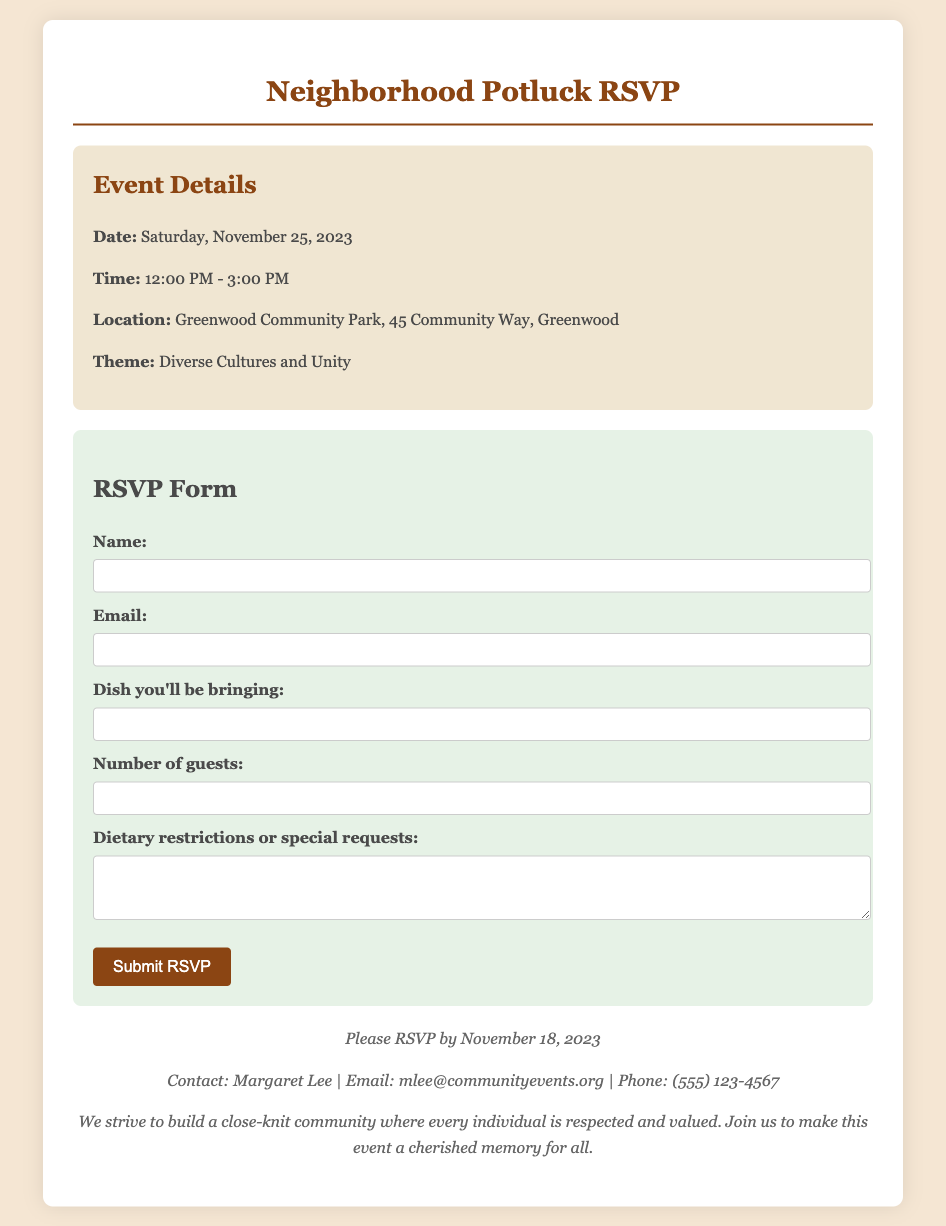what is the date of the event? The date of the event is specified in the document under Event Details.
Answer: Saturday, November 25, 2023 what time does the potluck start? The starting time of the potluck is indicated in the Event Details section of the document.
Answer: 12:00 PM where will the event take place? The location of the event is detailed in the Event Details section.
Answer: Greenwood Community Park, 45 Community Way, Greenwood what is the RSVP deadline? The RSVP deadline is mentioned in the footer section of the document.
Answer: November 18, 2023 who should be contacted for more information? The contact person for more information is provided in the footer section.
Answer: Margaret Lee what is the main theme of the potluck? The theme of the potluck is highlighted in the Event Details section.
Answer: Diverse Cultures and Unity how many guests can you bring? The number of guests can be indicated in the RSVP Form section of the document.
Answer: Variable (input field) is there a section for dietary restrictions? The document includes a section for special requests regarding dietary restrictions.
Answer: Yes 